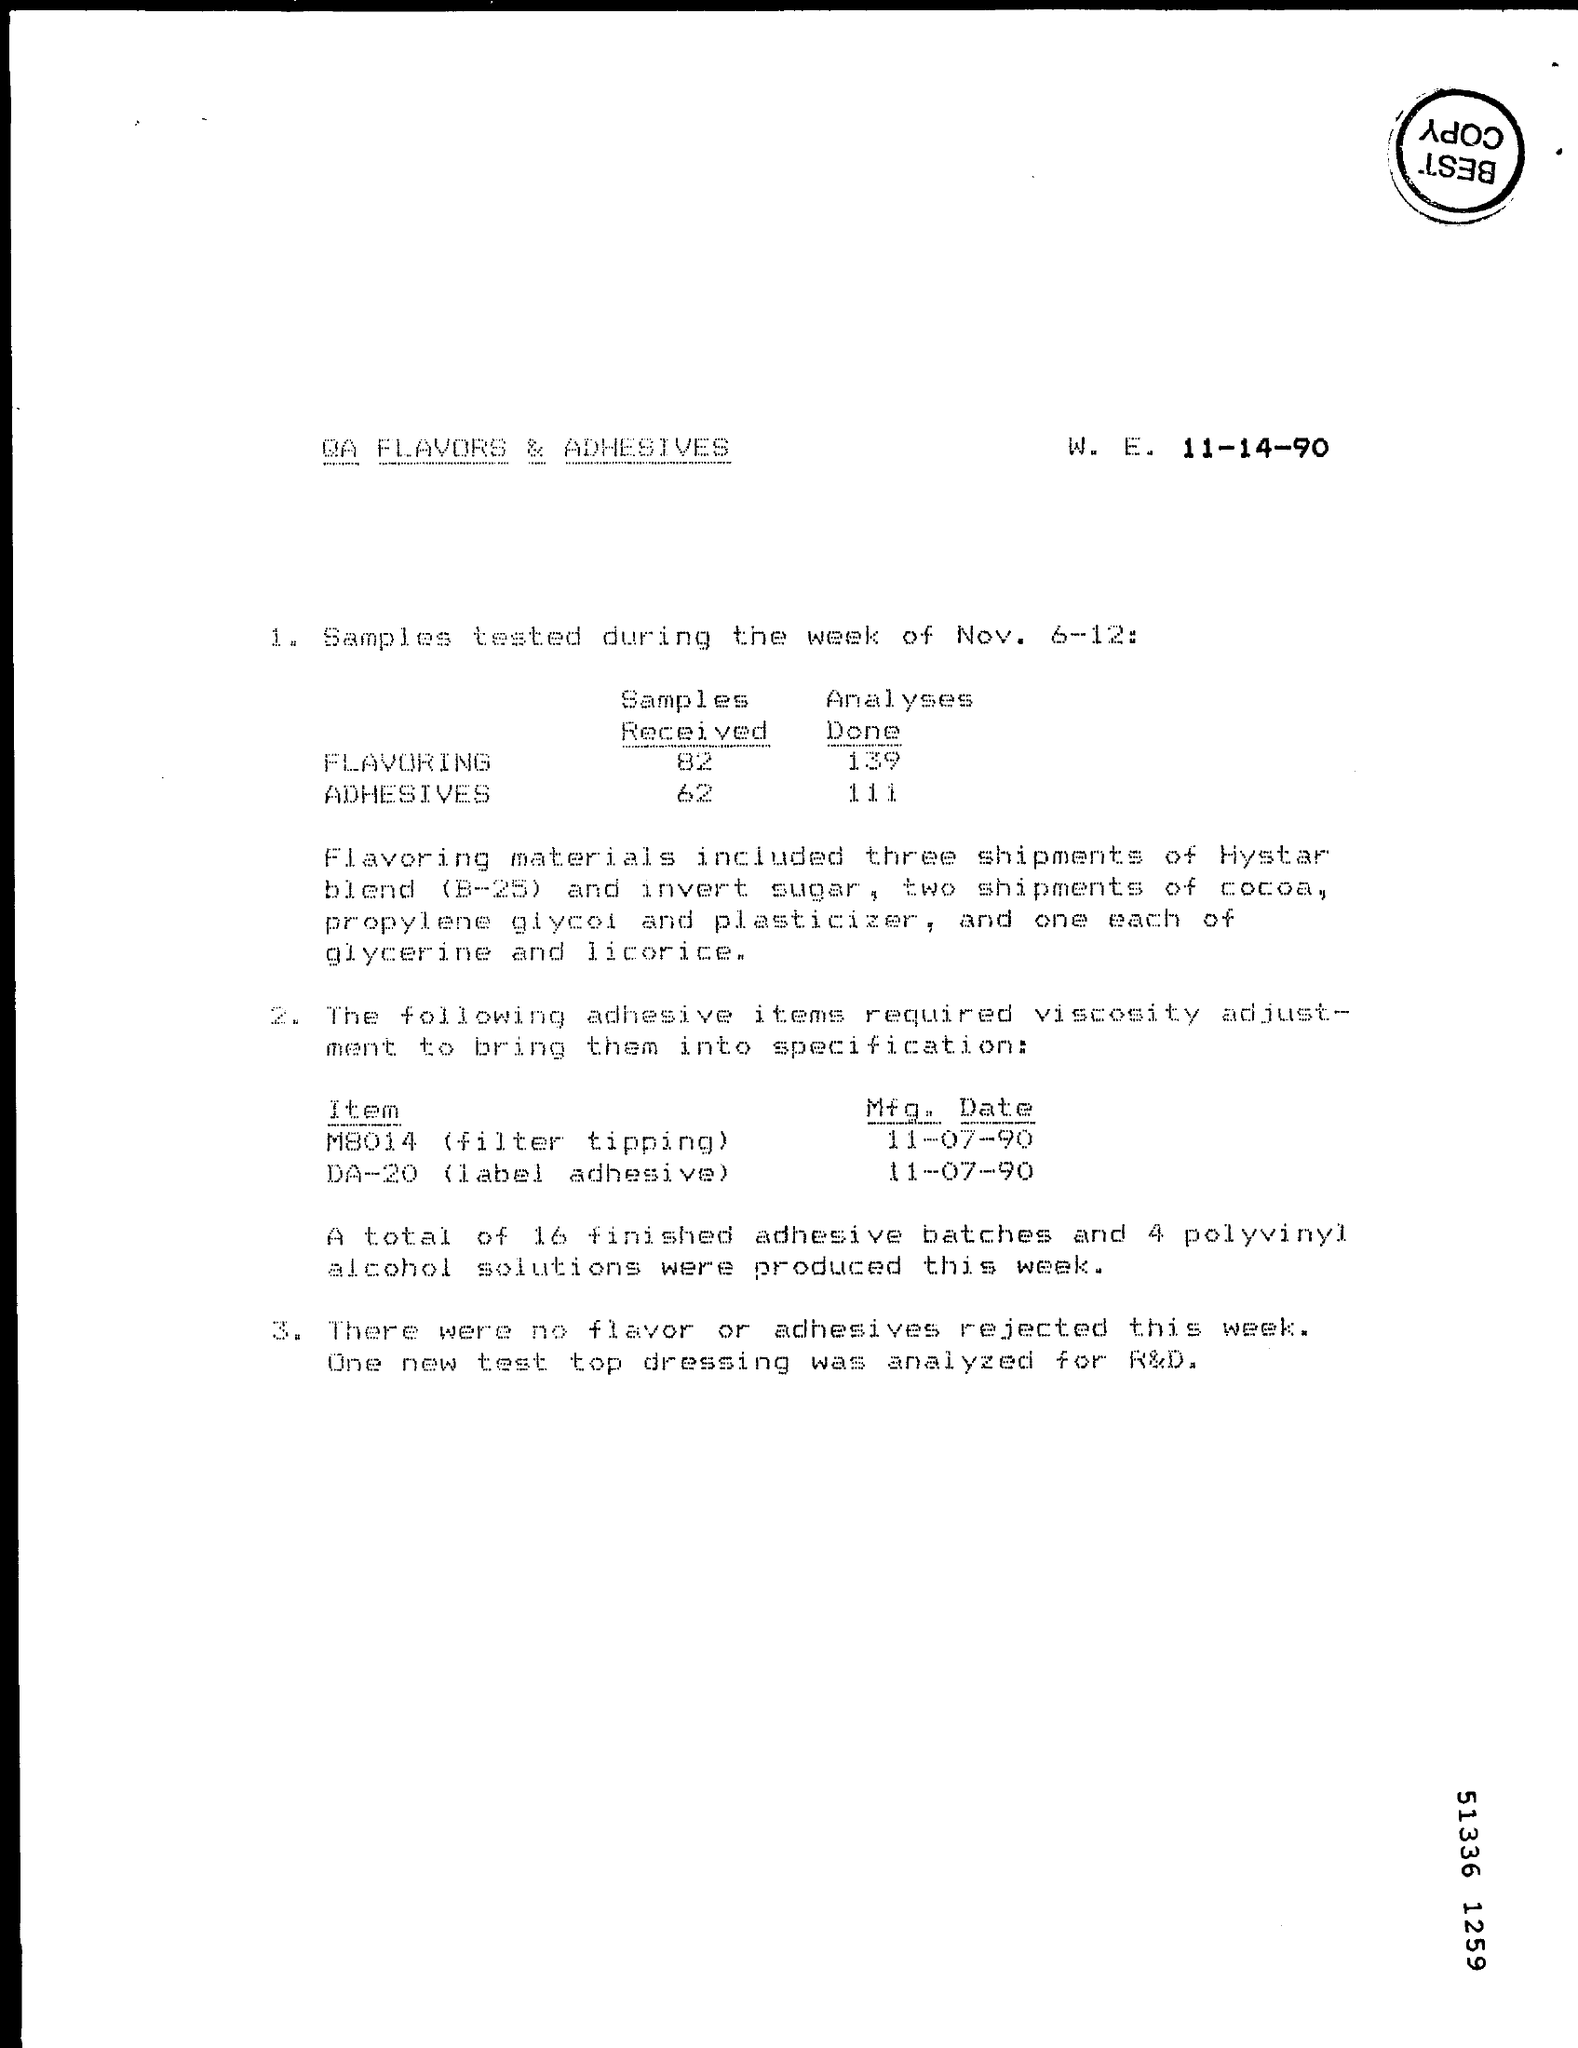What is the Title of the document?
Keep it short and to the point. QA Flavors & Adhesives. What is the Mfg. Date for Item M8014 (filter tipping)?
Provide a short and direct response. 11-07-90. What is the Mfg. Date for Item DA-20 (label adhesive)?
Offer a terse response. 11-07-90. 